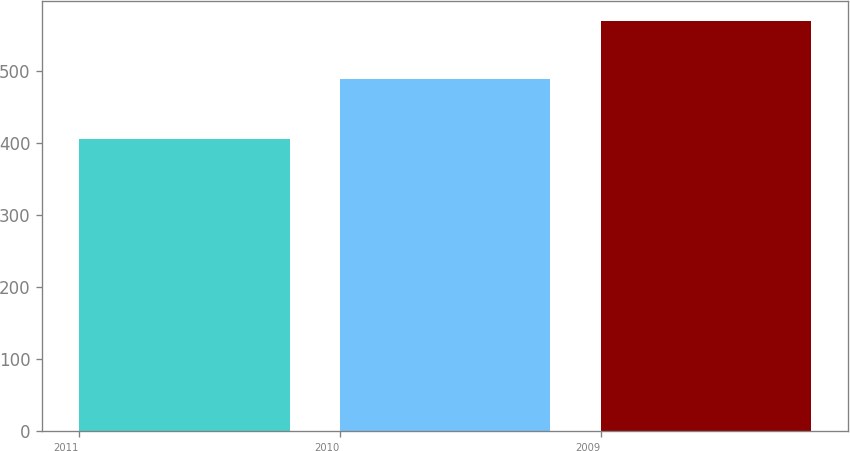<chart> <loc_0><loc_0><loc_500><loc_500><bar_chart><fcel>2011<fcel>2010<fcel>2009<nl><fcel>406<fcel>490<fcel>570<nl></chart> 